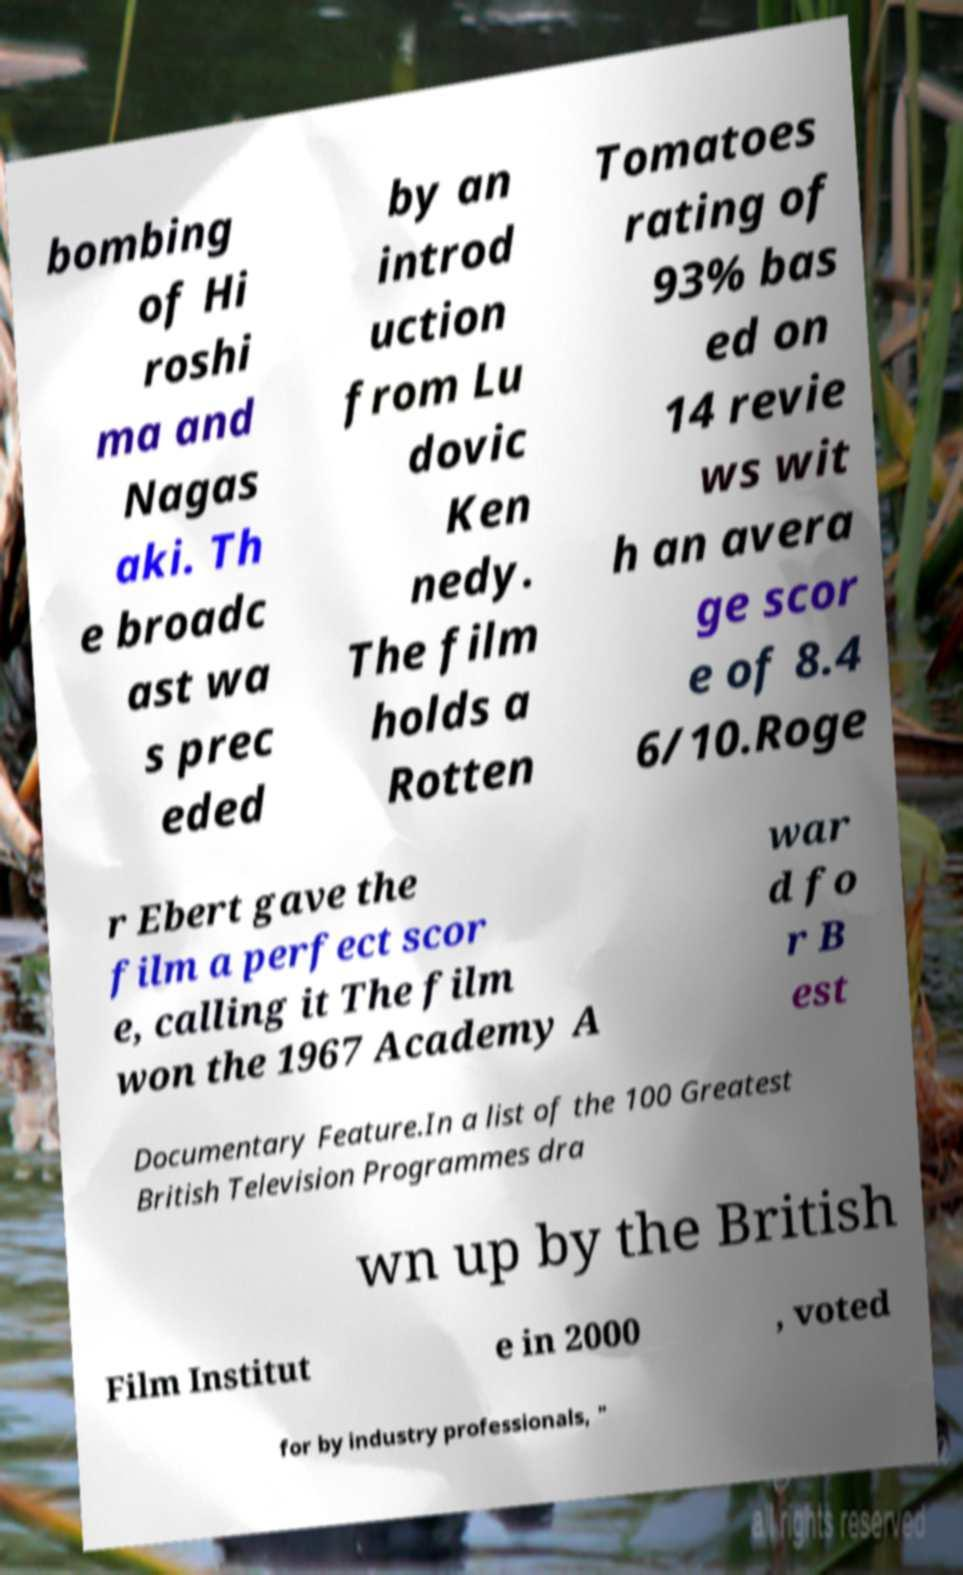Can you accurately transcribe the text from the provided image for me? bombing of Hi roshi ma and Nagas aki. Th e broadc ast wa s prec eded by an introd uction from Lu dovic Ken nedy. The film holds a Rotten Tomatoes rating of 93% bas ed on 14 revie ws wit h an avera ge scor e of 8.4 6/10.Roge r Ebert gave the film a perfect scor e, calling it The film won the 1967 Academy A war d fo r B est Documentary Feature.In a list of the 100 Greatest British Television Programmes dra wn up by the British Film Institut e in 2000 , voted for by industry professionals, " 